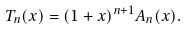Convert formula to latex. <formula><loc_0><loc_0><loc_500><loc_500>T _ { n } ( x ) = ( 1 + x ) ^ { n + 1 } A _ { n } ( x ) .</formula> 